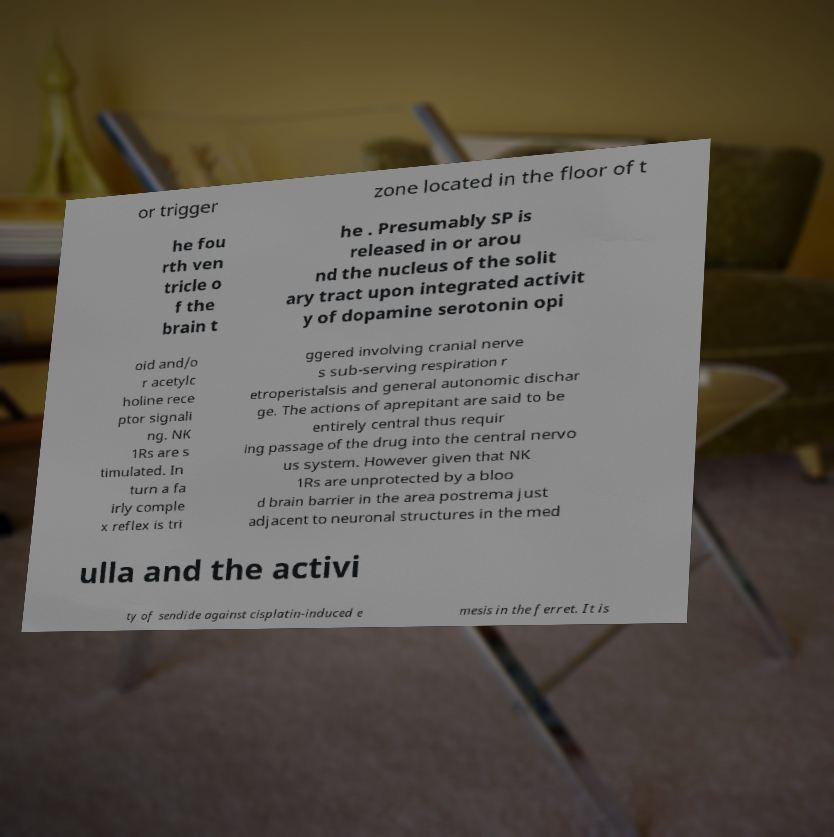I need the written content from this picture converted into text. Can you do that? or trigger zone located in the floor of t he fou rth ven tricle o f the brain t he . Presumably SP is released in or arou nd the nucleus of the solit ary tract upon integrated activit y of dopamine serotonin opi oid and/o r acetylc holine rece ptor signali ng. NK 1Rs are s timulated. In turn a fa irly comple x reflex is tri ggered involving cranial nerve s sub-serving respiration r etroperistalsis and general autonomic dischar ge. The actions of aprepitant are said to be entirely central thus requir ing passage of the drug into the central nervo us system. However given that NK 1Rs are unprotected by a bloo d brain barrier in the area postrema just adjacent to neuronal structures in the med ulla and the activi ty of sendide against cisplatin-induced e mesis in the ferret. It is 